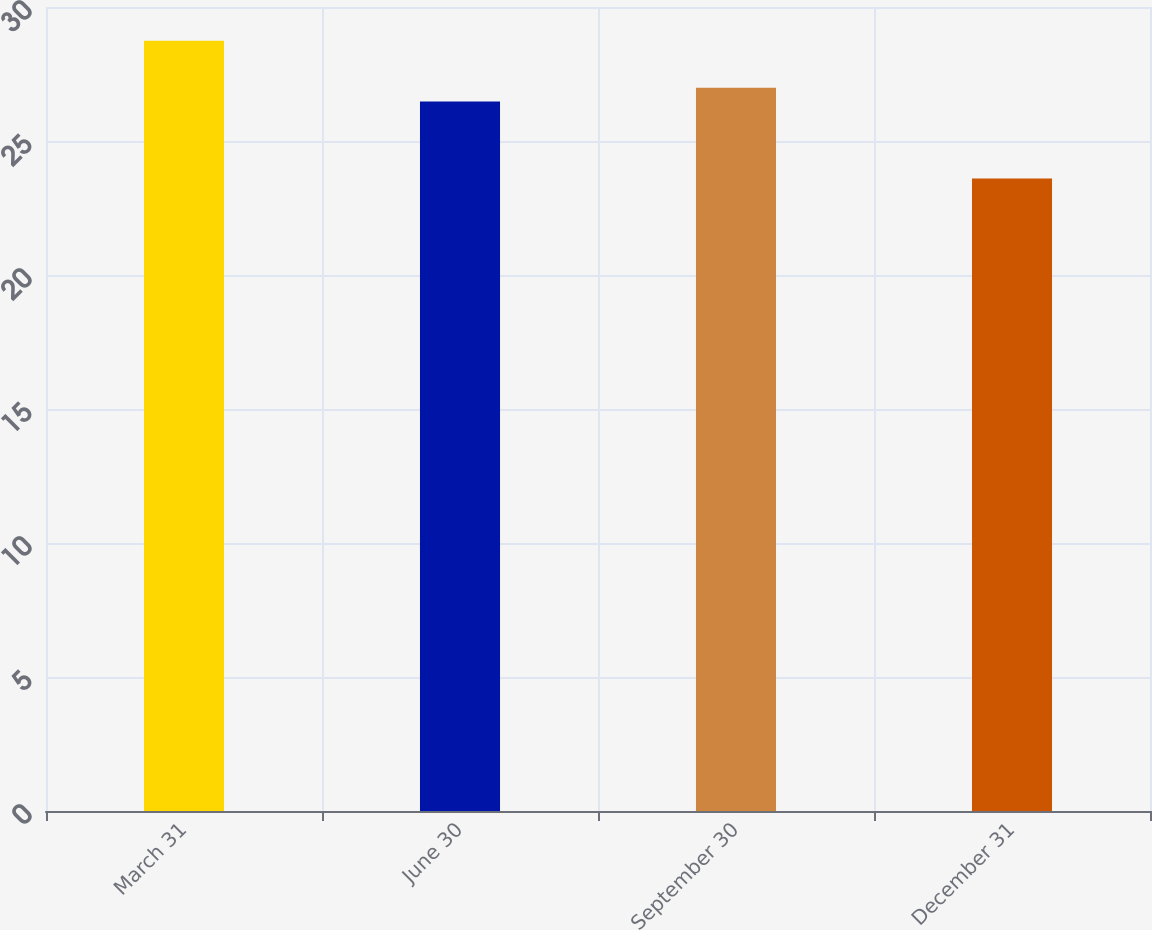<chart> <loc_0><loc_0><loc_500><loc_500><bar_chart><fcel>March 31<fcel>June 30<fcel>September 30<fcel>December 31<nl><fcel>28.74<fcel>26.47<fcel>26.99<fcel>23.6<nl></chart> 